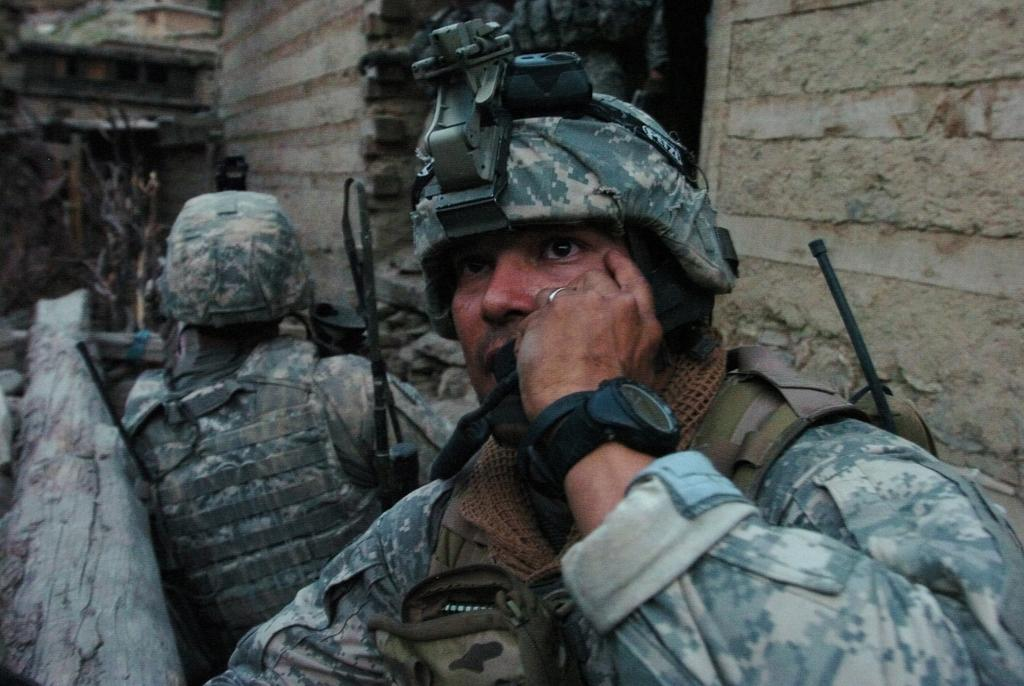How many people are present in the image? There are two people in the image. What are the people wearing? The two people are wearing uniforms. What can be seen in the background of the image? There is a wall in the background of the image. What type of shoes are the people wearing in the image? There is no information about shoes in the image, as the focus is on the people wearing uniforms. 